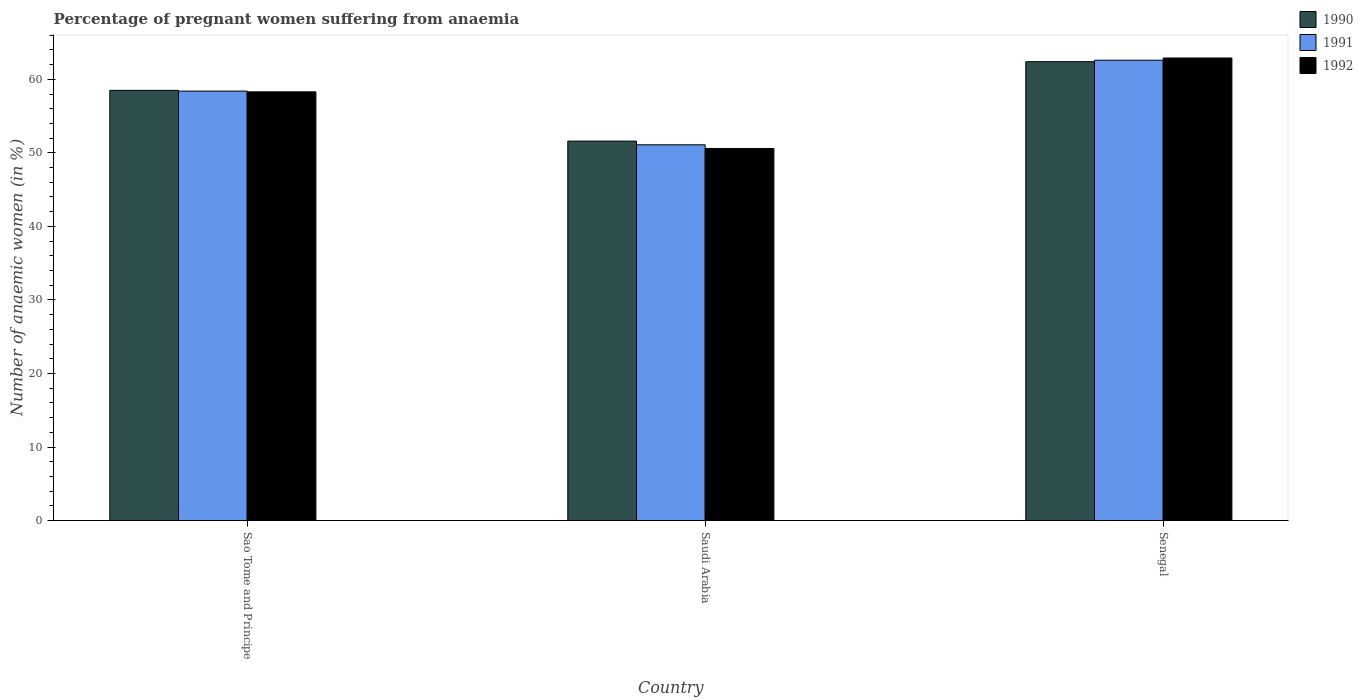What is the label of the 3rd group of bars from the left?
Your answer should be compact. Senegal. What is the number of anaemic women in 1992 in Senegal?
Keep it short and to the point. 62.9. Across all countries, what is the maximum number of anaemic women in 1990?
Give a very brief answer. 62.4. Across all countries, what is the minimum number of anaemic women in 1990?
Your response must be concise. 51.6. In which country was the number of anaemic women in 1992 maximum?
Make the answer very short. Senegal. In which country was the number of anaemic women in 1990 minimum?
Your answer should be compact. Saudi Arabia. What is the total number of anaemic women in 1990 in the graph?
Your answer should be very brief. 172.5. What is the difference between the number of anaemic women in 1992 in Sao Tome and Principe and that in Senegal?
Give a very brief answer. -4.6. What is the difference between the number of anaemic women in 1990 in Sao Tome and Principe and the number of anaemic women in 1992 in Senegal?
Ensure brevity in your answer.  -4.4. What is the average number of anaemic women in 1990 per country?
Your answer should be very brief. 57.5. What is the difference between the number of anaemic women of/in 1990 and number of anaemic women of/in 1992 in Sao Tome and Principe?
Ensure brevity in your answer.  0.2. What is the ratio of the number of anaemic women in 1990 in Sao Tome and Principe to that in Saudi Arabia?
Your answer should be compact. 1.13. Is the number of anaemic women in 1990 in Saudi Arabia less than that in Senegal?
Provide a short and direct response. Yes. What is the difference between the highest and the second highest number of anaemic women in 1991?
Your answer should be compact. 7.3. What is the difference between the highest and the lowest number of anaemic women in 1990?
Offer a very short reply. 10.8. Are all the bars in the graph horizontal?
Your answer should be compact. No. How many countries are there in the graph?
Provide a short and direct response. 3. Does the graph contain any zero values?
Keep it short and to the point. No. Where does the legend appear in the graph?
Give a very brief answer. Top right. How many legend labels are there?
Your response must be concise. 3. What is the title of the graph?
Make the answer very short. Percentage of pregnant women suffering from anaemia. Does "1966" appear as one of the legend labels in the graph?
Keep it short and to the point. No. What is the label or title of the X-axis?
Your answer should be very brief. Country. What is the label or title of the Y-axis?
Your response must be concise. Number of anaemic women (in %). What is the Number of anaemic women (in %) of 1990 in Sao Tome and Principe?
Provide a short and direct response. 58.5. What is the Number of anaemic women (in %) of 1991 in Sao Tome and Principe?
Offer a very short reply. 58.4. What is the Number of anaemic women (in %) of 1992 in Sao Tome and Principe?
Provide a short and direct response. 58.3. What is the Number of anaemic women (in %) in 1990 in Saudi Arabia?
Your answer should be compact. 51.6. What is the Number of anaemic women (in %) of 1991 in Saudi Arabia?
Give a very brief answer. 51.1. What is the Number of anaemic women (in %) of 1992 in Saudi Arabia?
Offer a terse response. 50.6. What is the Number of anaemic women (in %) in 1990 in Senegal?
Keep it short and to the point. 62.4. What is the Number of anaemic women (in %) of 1991 in Senegal?
Make the answer very short. 62.6. What is the Number of anaemic women (in %) of 1992 in Senegal?
Ensure brevity in your answer.  62.9. Across all countries, what is the maximum Number of anaemic women (in %) of 1990?
Make the answer very short. 62.4. Across all countries, what is the maximum Number of anaemic women (in %) in 1991?
Offer a very short reply. 62.6. Across all countries, what is the maximum Number of anaemic women (in %) in 1992?
Keep it short and to the point. 62.9. Across all countries, what is the minimum Number of anaemic women (in %) in 1990?
Your answer should be compact. 51.6. Across all countries, what is the minimum Number of anaemic women (in %) in 1991?
Provide a succinct answer. 51.1. Across all countries, what is the minimum Number of anaemic women (in %) in 1992?
Your response must be concise. 50.6. What is the total Number of anaemic women (in %) of 1990 in the graph?
Offer a terse response. 172.5. What is the total Number of anaemic women (in %) of 1991 in the graph?
Make the answer very short. 172.1. What is the total Number of anaemic women (in %) in 1992 in the graph?
Offer a terse response. 171.8. What is the difference between the Number of anaemic women (in %) in 1991 in Sao Tome and Principe and that in Saudi Arabia?
Your answer should be very brief. 7.3. What is the difference between the Number of anaemic women (in %) of 1991 in Sao Tome and Principe and that in Senegal?
Provide a succinct answer. -4.2. What is the difference between the Number of anaemic women (in %) of 1992 in Sao Tome and Principe and that in Senegal?
Your answer should be compact. -4.6. What is the difference between the Number of anaemic women (in %) in 1991 in Saudi Arabia and that in Senegal?
Make the answer very short. -11.5. What is the difference between the Number of anaemic women (in %) in 1990 in Sao Tome and Principe and the Number of anaemic women (in %) in 1991 in Saudi Arabia?
Your response must be concise. 7.4. What is the difference between the Number of anaemic women (in %) of 1990 in Sao Tome and Principe and the Number of anaemic women (in %) of 1992 in Saudi Arabia?
Make the answer very short. 7.9. What is the difference between the Number of anaemic women (in %) of 1991 in Sao Tome and Principe and the Number of anaemic women (in %) of 1992 in Saudi Arabia?
Offer a terse response. 7.8. What is the difference between the Number of anaemic women (in %) in 1991 in Sao Tome and Principe and the Number of anaemic women (in %) in 1992 in Senegal?
Offer a very short reply. -4.5. What is the difference between the Number of anaemic women (in %) of 1991 in Saudi Arabia and the Number of anaemic women (in %) of 1992 in Senegal?
Keep it short and to the point. -11.8. What is the average Number of anaemic women (in %) in 1990 per country?
Your answer should be compact. 57.5. What is the average Number of anaemic women (in %) of 1991 per country?
Make the answer very short. 57.37. What is the average Number of anaemic women (in %) in 1992 per country?
Make the answer very short. 57.27. What is the difference between the Number of anaemic women (in %) of 1990 and Number of anaemic women (in %) of 1991 in Sao Tome and Principe?
Your answer should be very brief. 0.1. What is the difference between the Number of anaemic women (in %) in 1990 and Number of anaemic women (in %) in 1992 in Sao Tome and Principe?
Give a very brief answer. 0.2. What is the difference between the Number of anaemic women (in %) of 1990 and Number of anaemic women (in %) of 1991 in Saudi Arabia?
Make the answer very short. 0.5. What is the difference between the Number of anaemic women (in %) of 1990 and Number of anaemic women (in %) of 1991 in Senegal?
Your answer should be compact. -0.2. What is the difference between the Number of anaemic women (in %) in 1990 and Number of anaemic women (in %) in 1992 in Senegal?
Provide a succinct answer. -0.5. What is the difference between the Number of anaemic women (in %) in 1991 and Number of anaemic women (in %) in 1992 in Senegal?
Ensure brevity in your answer.  -0.3. What is the ratio of the Number of anaemic women (in %) in 1990 in Sao Tome and Principe to that in Saudi Arabia?
Provide a short and direct response. 1.13. What is the ratio of the Number of anaemic women (in %) of 1991 in Sao Tome and Principe to that in Saudi Arabia?
Ensure brevity in your answer.  1.14. What is the ratio of the Number of anaemic women (in %) of 1992 in Sao Tome and Principe to that in Saudi Arabia?
Give a very brief answer. 1.15. What is the ratio of the Number of anaemic women (in %) of 1990 in Sao Tome and Principe to that in Senegal?
Offer a very short reply. 0.94. What is the ratio of the Number of anaemic women (in %) in 1991 in Sao Tome and Principe to that in Senegal?
Your answer should be very brief. 0.93. What is the ratio of the Number of anaemic women (in %) in 1992 in Sao Tome and Principe to that in Senegal?
Provide a short and direct response. 0.93. What is the ratio of the Number of anaemic women (in %) in 1990 in Saudi Arabia to that in Senegal?
Give a very brief answer. 0.83. What is the ratio of the Number of anaemic women (in %) in 1991 in Saudi Arabia to that in Senegal?
Your answer should be very brief. 0.82. What is the ratio of the Number of anaemic women (in %) of 1992 in Saudi Arabia to that in Senegal?
Make the answer very short. 0.8. What is the difference between the highest and the second highest Number of anaemic women (in %) of 1990?
Ensure brevity in your answer.  3.9. What is the difference between the highest and the second highest Number of anaemic women (in %) in 1991?
Your response must be concise. 4.2. What is the difference between the highest and the lowest Number of anaemic women (in %) of 1991?
Make the answer very short. 11.5. What is the difference between the highest and the lowest Number of anaemic women (in %) in 1992?
Provide a succinct answer. 12.3. 